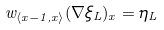<formula> <loc_0><loc_0><loc_500><loc_500>w _ { \langle x - 1 , x \rangle } ( \nabla \xi _ { L } ) _ { x } = \eta _ { L }</formula> 